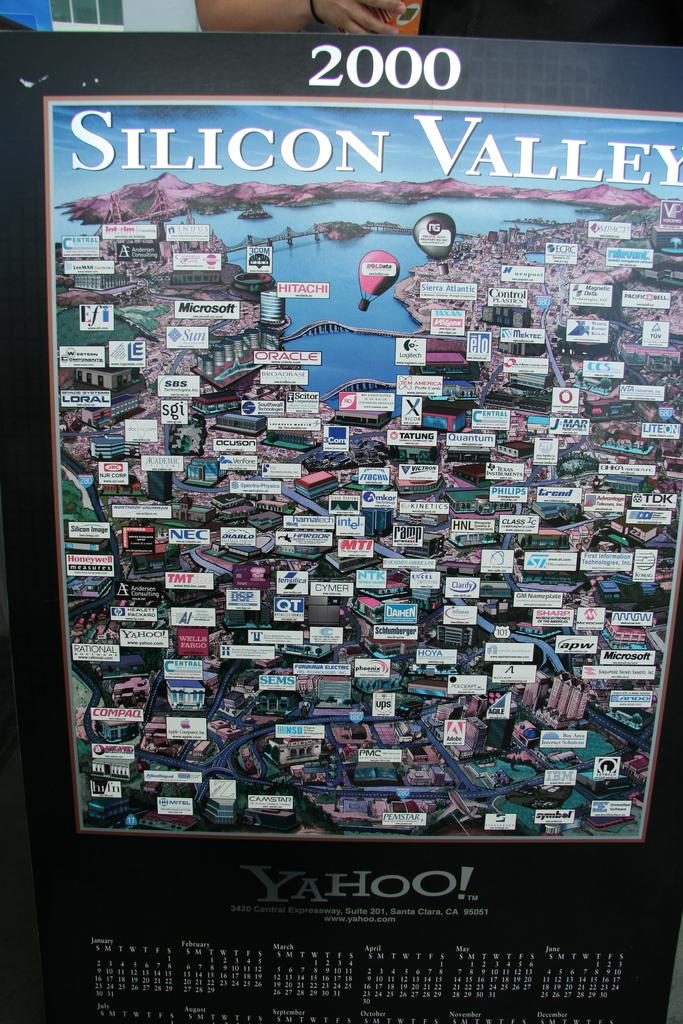<image>
Share a concise interpretation of the image provided. a Silicon Valley image with the year 2000 on it 